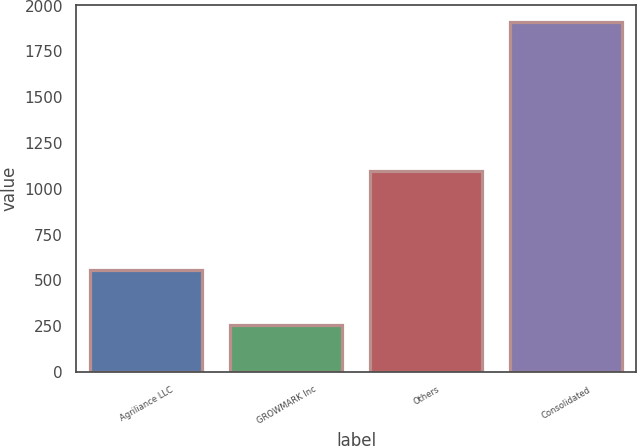<chart> <loc_0><loc_0><loc_500><loc_500><bar_chart><fcel>Agriliance LLC<fcel>GROWMARK Inc<fcel>Others<fcel>Consolidated<nl><fcel>555.9<fcel>255.2<fcel>1097.3<fcel>1908.4<nl></chart> 